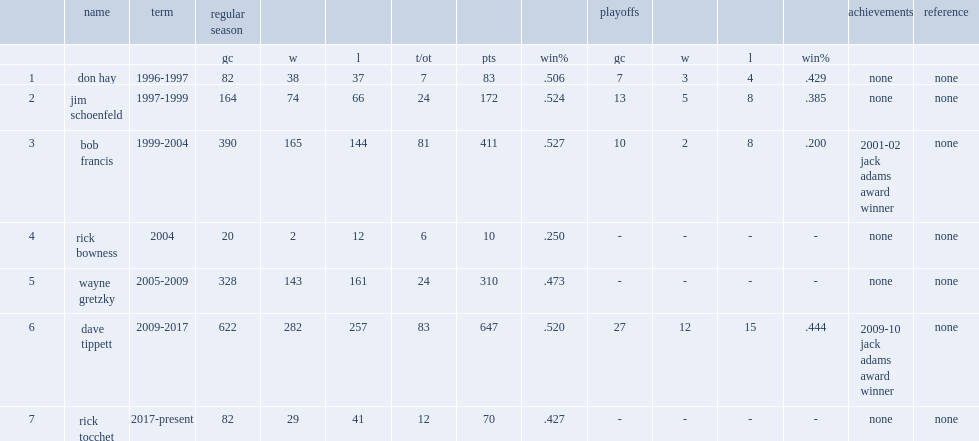Who had the most regular season and the most playoffs games coached? Dave tippett. 